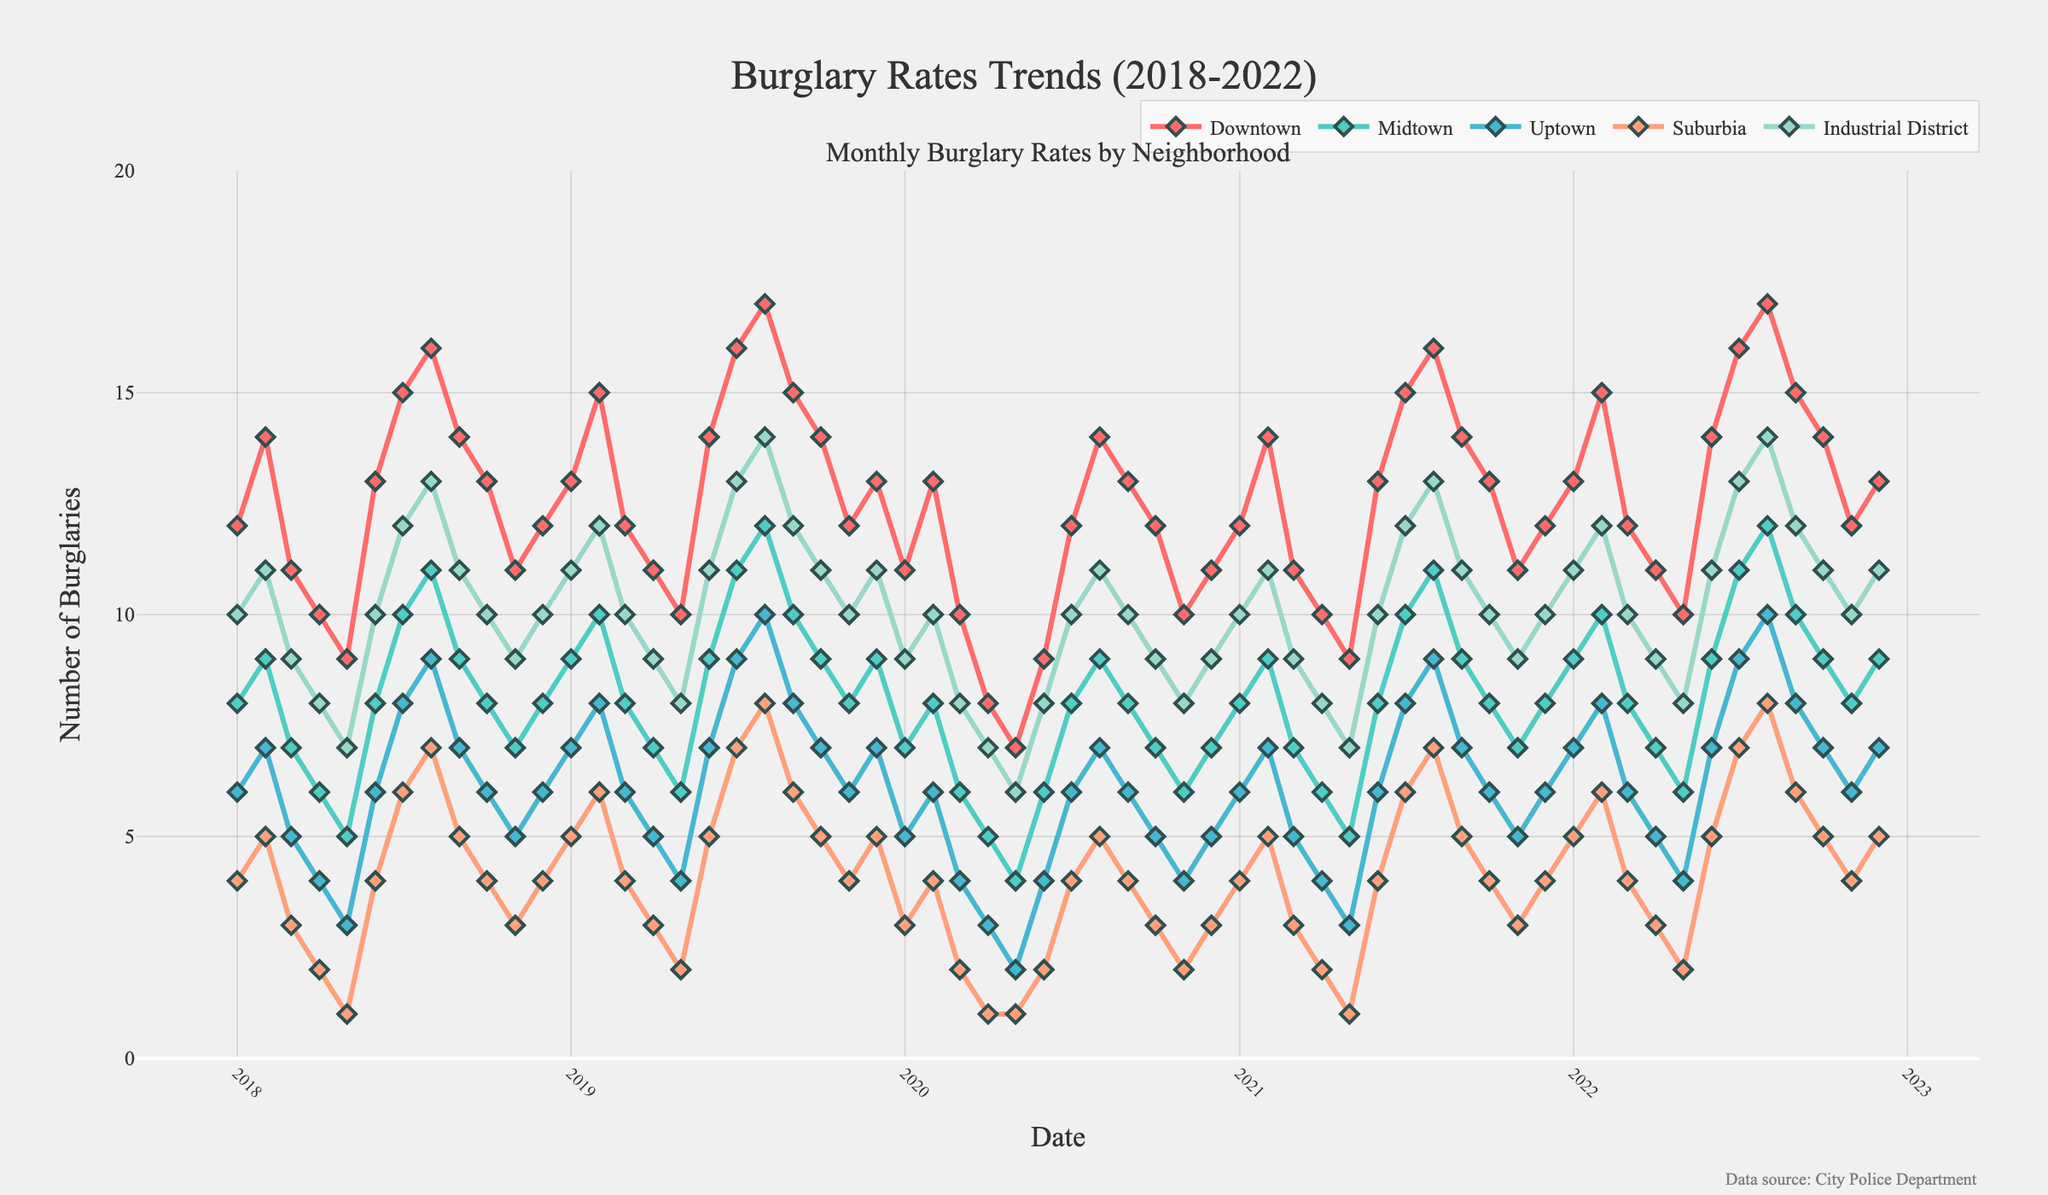Which neighborhood had the highest burglary rate in December 2022? Look at the last data point (2022-12) for each neighborhood in the figure and compare the values. The highest value is from Downtown.
Answer: Downtown What is the overall trend of burglary rates in Suburbia from 2018 to 2022? Check the curve representing Suburbia over the period from 2018 to 2022. You can notice that the trend shows a gradual increase from 2018 till 2022 with some fluctuations.
Answer: Increasing How did the burglary rate in the Industrial District change from January 2018 to December 2022? Compare the data points at January 2018 (10 burglaries) and December 2022 (11 burglaries) for the Industrial District. The rate increased slightly overall, despite fluctuations.
Answer: Slightly increased Compare the burglary rates in Downtown and Midtown for May 2020. Which neighborhood had a higher rate? Check the data points at May 2020 for both Downtown and Midtown. Downtown shows 7 burglaries, while Midtown shows 4 burglaries.
Answer: Downtown What's the average burglary rate in Uptown for the year 2019? Sum the monthly burglary rates for Uptown from January 2019 to December 2019 and divide by 12. The numbers are 7+8+6+5+4+7+9+10+8+7+6+7, totaling 84, and 84/12 = 7.
Answer: 7 Which neighborhood had the fewest burglaries in July 2021, and what was the count? Compare the data points for July 2021 across all neighborhoods. Suburbia had the fewest with 3 burglaries.
Answer: Suburbia, 3 By how much did the burglary rate in Midtown decrease from July 2020 to August 2020? Compare the burglary rates for Midtown in July 2020 (8 burglaries) and August 2020 (6 burglaries). The decrease is 8 - 6 = 2.
Answer: 2 What is the color of the line representing Uptown in the figure? Look at the legend or the lines in the plot. Uptown is represented by a blue line.
Answer: Blue 